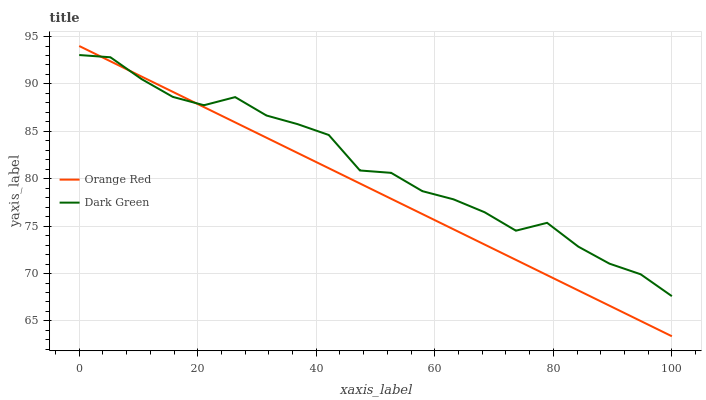Does Orange Red have the minimum area under the curve?
Answer yes or no. Yes. Does Dark Green have the maximum area under the curve?
Answer yes or no. Yes. Does Dark Green have the minimum area under the curve?
Answer yes or no. No. Is Orange Red the smoothest?
Answer yes or no. Yes. Is Dark Green the roughest?
Answer yes or no. Yes. Is Dark Green the smoothest?
Answer yes or no. No. Does Orange Red have the lowest value?
Answer yes or no. Yes. Does Dark Green have the lowest value?
Answer yes or no. No. Does Orange Red have the highest value?
Answer yes or no. Yes. Does Dark Green have the highest value?
Answer yes or no. No. Does Orange Red intersect Dark Green?
Answer yes or no. Yes. Is Orange Red less than Dark Green?
Answer yes or no. No. Is Orange Red greater than Dark Green?
Answer yes or no. No. 